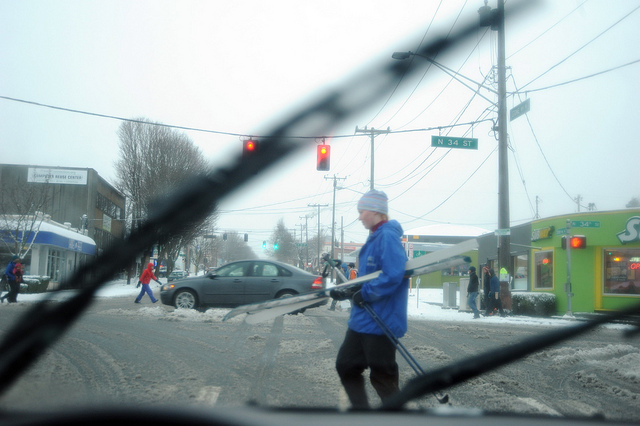Please identify all text content in this image. N 34 ST 